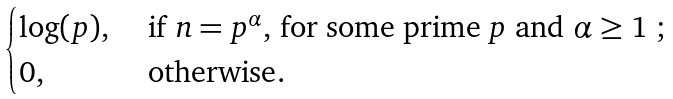Convert formula to latex. <formula><loc_0><loc_0><loc_500><loc_500>\begin{cases} \log ( p ) , & \text { if $n=p^{\alpha},$ for some prime $p$ and $\alpha \geq 1$ ;} \\ 0 , & \text { otherwise} . \end{cases}</formula> 